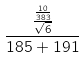<formula> <loc_0><loc_0><loc_500><loc_500>\frac { \frac { \frac { 1 0 } { 3 8 3 } } { \sqrt { 6 } } } { 1 8 5 + 1 9 1 }</formula> 